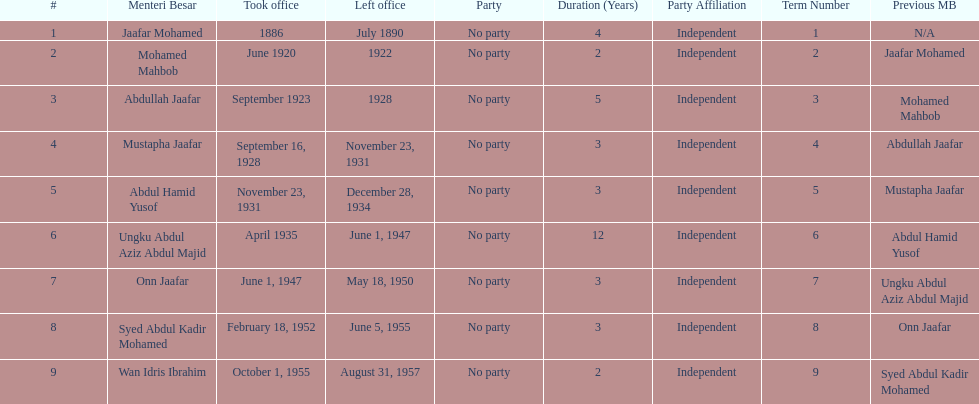What is the number of menteri besars that there have been during the pre-independence period? 9. I'm looking to parse the entire table for insights. Could you assist me with that? {'header': ['#', 'Menteri Besar', 'Took office', 'Left office', 'Party', 'Duration (Years)', 'Party Affiliation', 'Term Number', 'Previous MB'], 'rows': [['1', 'Jaafar Mohamed', '1886', 'July 1890', 'No party', '4', 'Independent', '1', 'N/A'], ['2', 'Mohamed Mahbob', 'June 1920', '1922', 'No party', '2', 'Independent', '2', 'Jaafar Mohamed'], ['3', 'Abdullah Jaafar', 'September 1923', '1928', 'No party', '5', 'Independent', '3', 'Mohamed Mahbob'], ['4', 'Mustapha Jaafar', 'September 16, 1928', 'November 23, 1931', 'No party', '3', 'Independent', '4', 'Abdullah Jaafar'], ['5', 'Abdul Hamid Yusof', 'November 23, 1931', 'December 28, 1934', 'No party', '3', 'Independent', '5', 'Mustapha Jaafar'], ['6', 'Ungku Abdul Aziz Abdul Majid', 'April 1935', 'June 1, 1947', 'No party', '12', 'Independent', '6', 'Abdul Hamid Yusof'], ['7', 'Onn Jaafar', 'June 1, 1947', 'May 18, 1950', 'No party', '3', 'Independent', '7', 'Ungku Abdul Aziz Abdul Majid'], ['8', 'Syed Abdul Kadir Mohamed', 'February 18, 1952', 'June 5, 1955', 'No party', '3', 'Independent', '8', 'Onn Jaafar'], ['9', 'Wan Idris Ibrahim', 'October 1, 1955', 'August 31, 1957', 'No party', '2', 'Independent', '9', 'Syed Abdul Kadir Mohamed']]} 